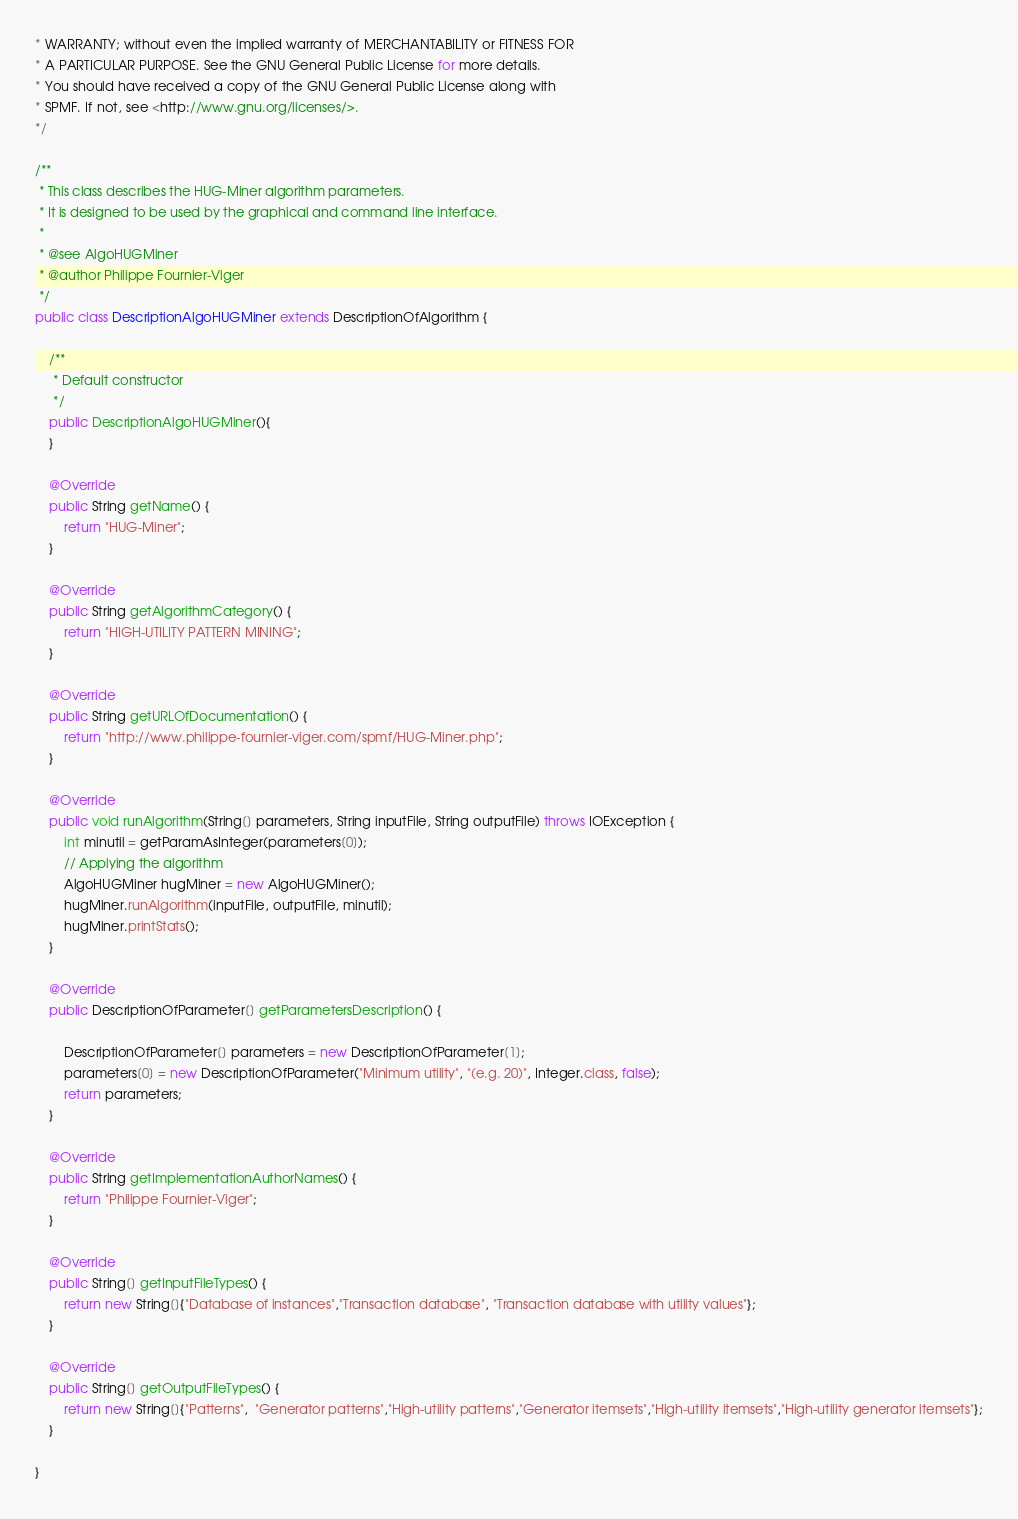Convert code to text. <code><loc_0><loc_0><loc_500><loc_500><_Java_>* WARRANTY; without even the implied warranty of MERCHANTABILITY or FITNESS FOR
* A PARTICULAR PURPOSE. See the GNU General Public License for more details.
* You should have received a copy of the GNU General Public License along with
* SPMF. If not, see <http://www.gnu.org/licenses/>.
*/

/**
 * This class describes the HUG-Miner algorithm parameters. 
 * It is designed to be used by the graphical and command line interface.
 * 
 * @see AlgoHUGMiner
 * @author Philippe Fournier-Viger
 */
public class DescriptionAlgoHUGMiner extends DescriptionOfAlgorithm {

	/**
	 * Default constructor
	 */
	public DescriptionAlgoHUGMiner(){
	}

	@Override
	public String getName() {
		return "HUG-Miner";
	}

	@Override
	public String getAlgorithmCategory() {
		return "HIGH-UTILITY PATTERN MINING";
	}

	@Override
	public String getURLOfDocumentation() {
		return "http://www.philippe-fournier-viger.com/spmf/HUG-Miner.php";
	}

	@Override
	public void runAlgorithm(String[] parameters, String inputFile, String outputFile) throws IOException {
		int minutil = getParamAsInteger(parameters[0]);
		// Applying the algorithm
		AlgoHUGMiner hugMiner = new AlgoHUGMiner();
		hugMiner.runAlgorithm(inputFile, outputFile, minutil);
		hugMiner.printStats();
	}

	@Override
	public DescriptionOfParameter[] getParametersDescription() {
        
		DescriptionOfParameter[] parameters = new DescriptionOfParameter[1];
		parameters[0] = new DescriptionOfParameter("Minimum utility", "(e.g. 20)", Integer.class, false);
		return parameters;
	}

	@Override
	public String getImplementationAuthorNames() {
		return "Philippe Fournier-Viger";
	}

	@Override
	public String[] getInputFileTypes() {
		return new String[]{"Database of instances","Transaction database", "Transaction database with utility values"};
	}

	@Override
	public String[] getOutputFileTypes() {
		return new String[]{"Patterns",  "Generator patterns","High-utility patterns","Generator itemsets","High-utility itemsets","High-utility generator itemsets"};
	}
	
}
</code> 